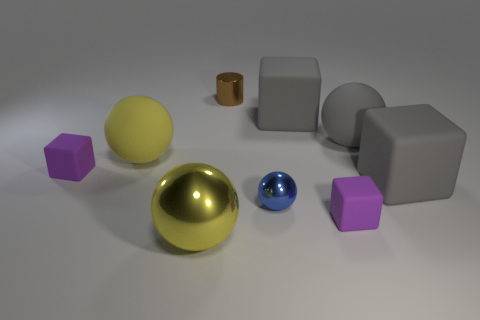Add 1 tiny green matte things. How many objects exist? 10 Subtract all big metal balls. How many balls are left? 3 Subtract 2 balls. How many balls are left? 2 Subtract all gray blocks. How many blocks are left? 2 Subtract all blue metallic objects. Subtract all tiny purple matte cubes. How many objects are left? 6 Add 3 yellow objects. How many yellow objects are left? 5 Add 4 small green blocks. How many small green blocks exist? 4 Subtract 0 gray cylinders. How many objects are left? 9 Subtract all blocks. How many objects are left? 5 Subtract all brown blocks. Subtract all green cylinders. How many blocks are left? 4 